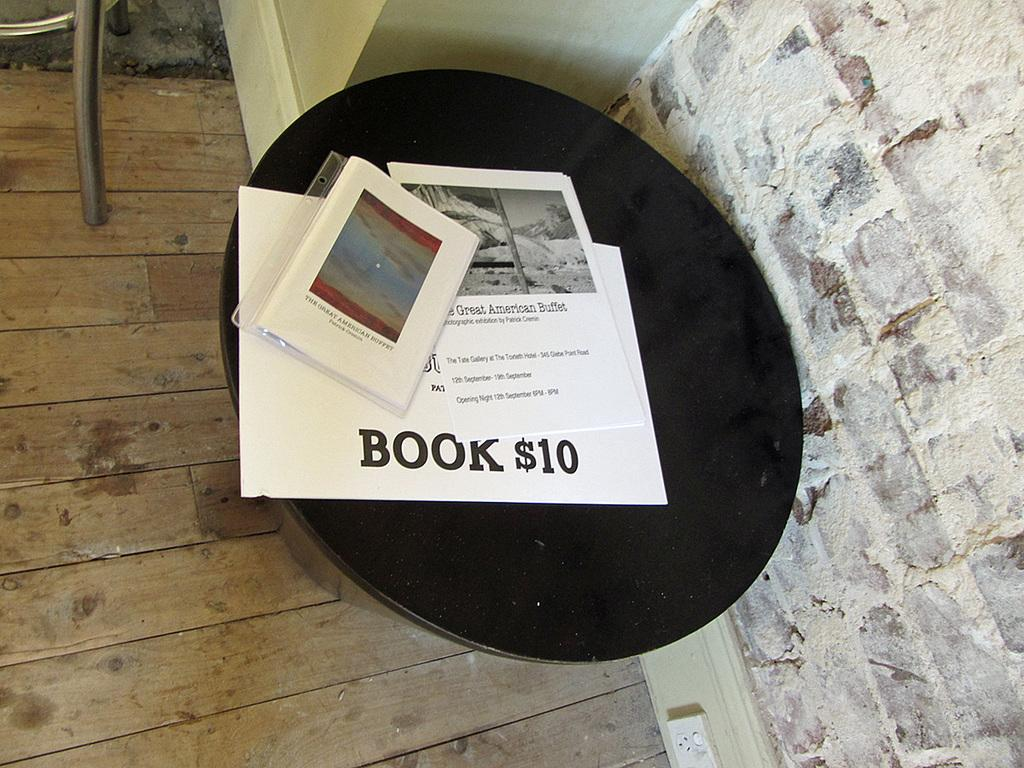What is on the table in the image? There are papers and other objects on the table in the image. What is the color of the table? The table is black in color. What can be seen on the right side of the image? There is a wall on the right side of the image. What is on the floor on the left side of the image? There is an object on the floor on the left side of the image. Can you see a kitty playing with a snail on the table in the image? No, there is no kitty or snail present on the table in the image. 